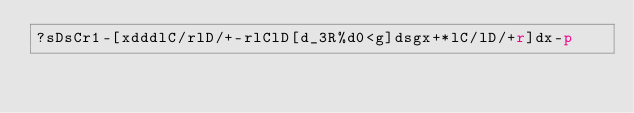Convert code to text. <code><loc_0><loc_0><loc_500><loc_500><_dc_>?sDsCr1-[xdddlC/rlD/+-rlClD[d_3R%d0<g]dsgx+*lC/lD/+r]dx-p</code> 